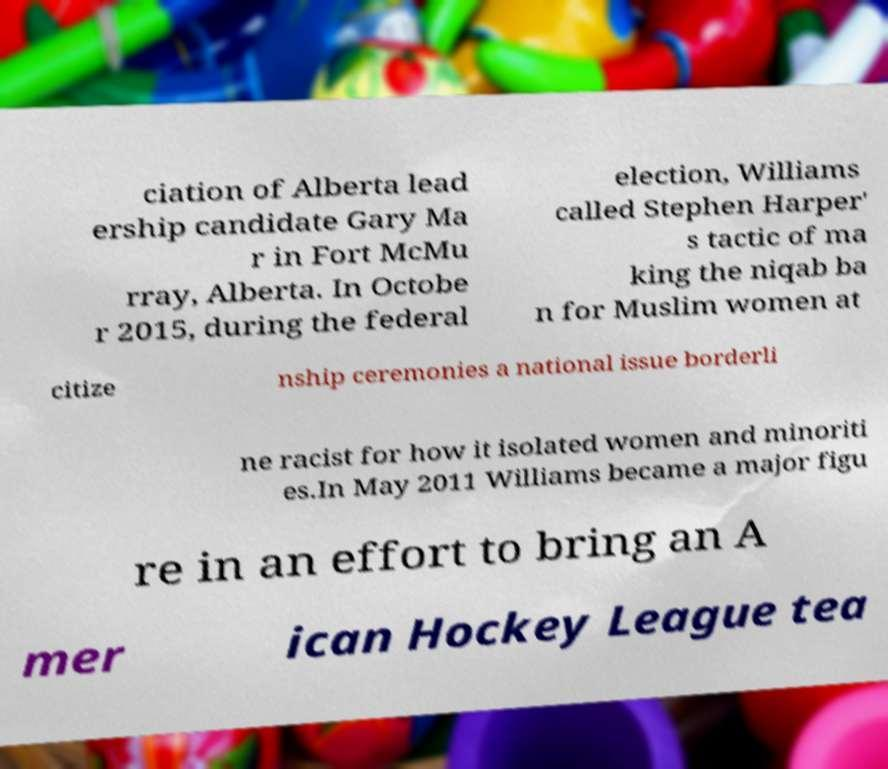What messages or text are displayed in this image? I need them in a readable, typed format. ciation of Alberta lead ership candidate Gary Ma r in Fort McMu rray, Alberta. In Octobe r 2015, during the federal election, Williams called Stephen Harper' s tactic of ma king the niqab ba n for Muslim women at citize nship ceremonies a national issue borderli ne racist for how it isolated women and minoriti es.In May 2011 Williams became a major figu re in an effort to bring an A mer ican Hockey League tea 